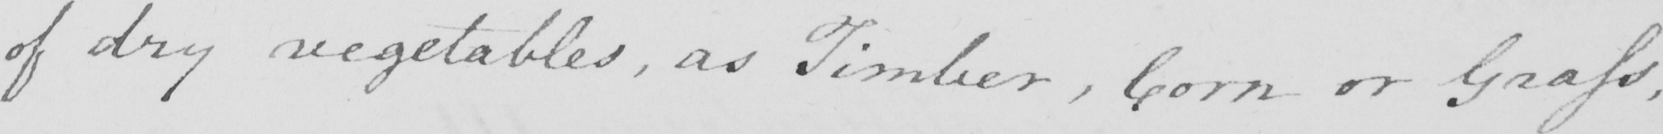What is written in this line of handwriting? of dry vegetables , as Timber , Corn or Grass , 